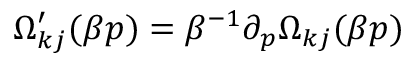<formula> <loc_0><loc_0><loc_500><loc_500>\Omega _ { k j } ^ { \prime } ( \beta p ) = \beta ^ { - 1 } \partial _ { p } \Omega _ { k j } ( \beta p )</formula> 